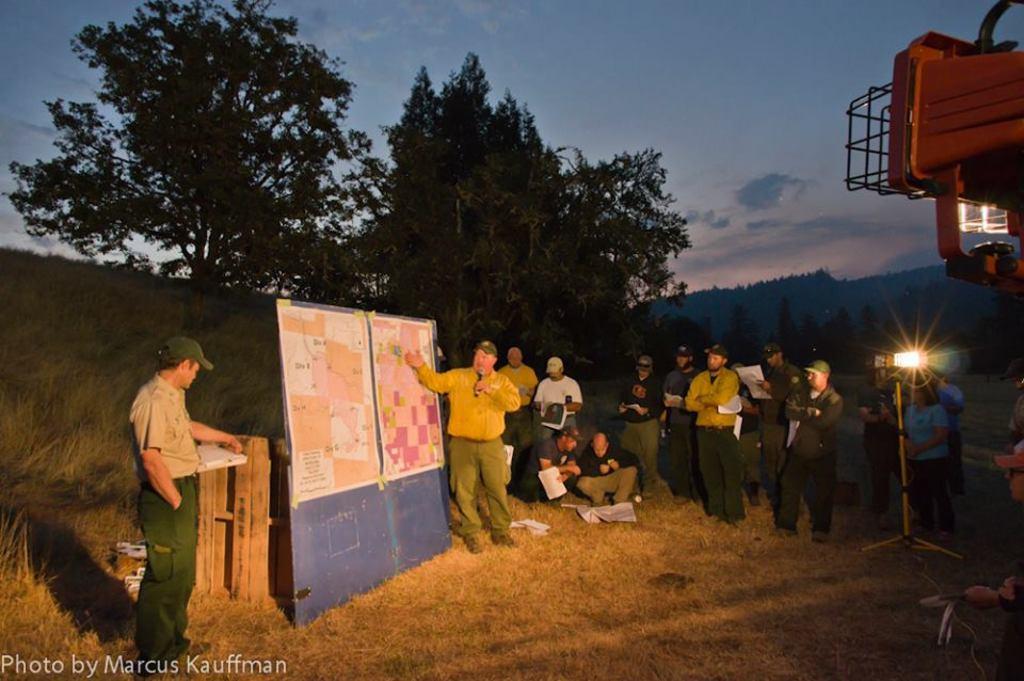Describe this image in one or two sentences. There are people,this man holding a microphone and few people are holding papers. We can see posts on a board,grass,light with stand and object. In the background we can see trees and sky with clouds. 